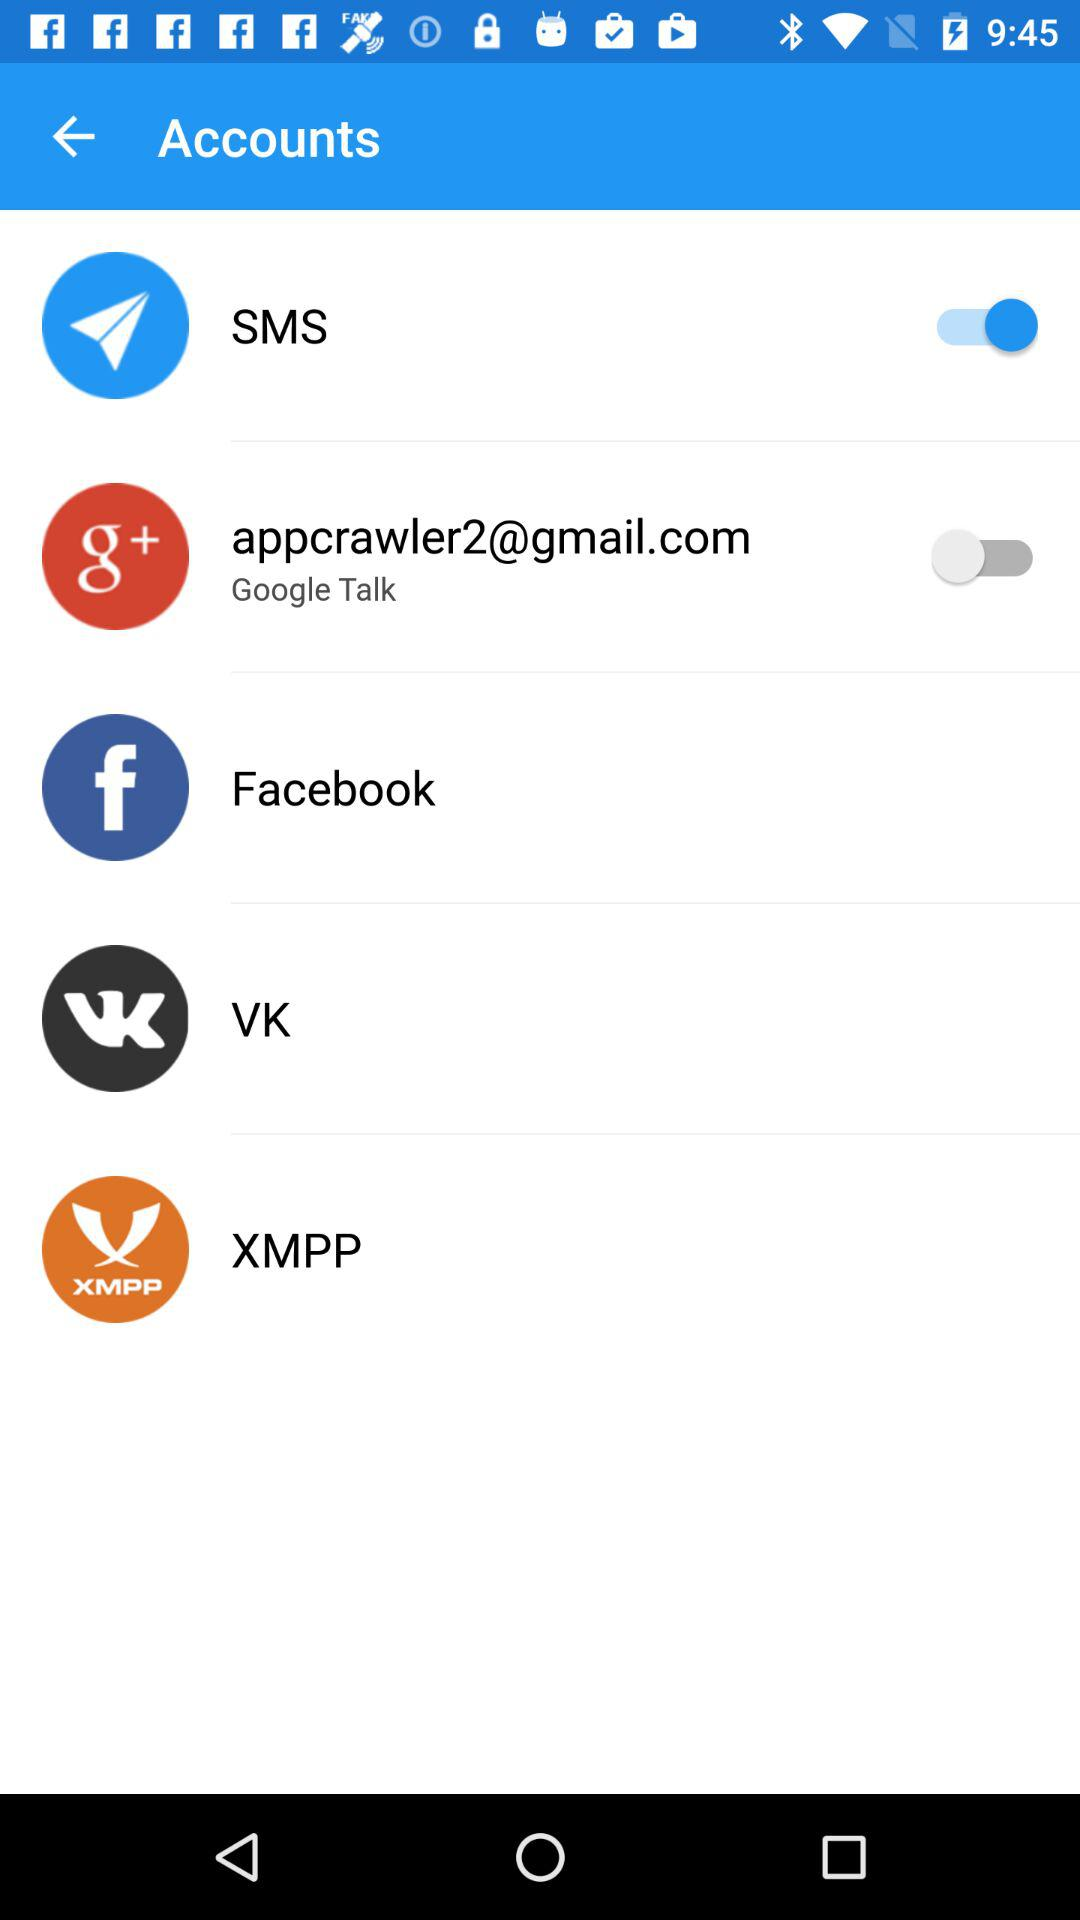What is the status of "SMS"? The status is "on". 